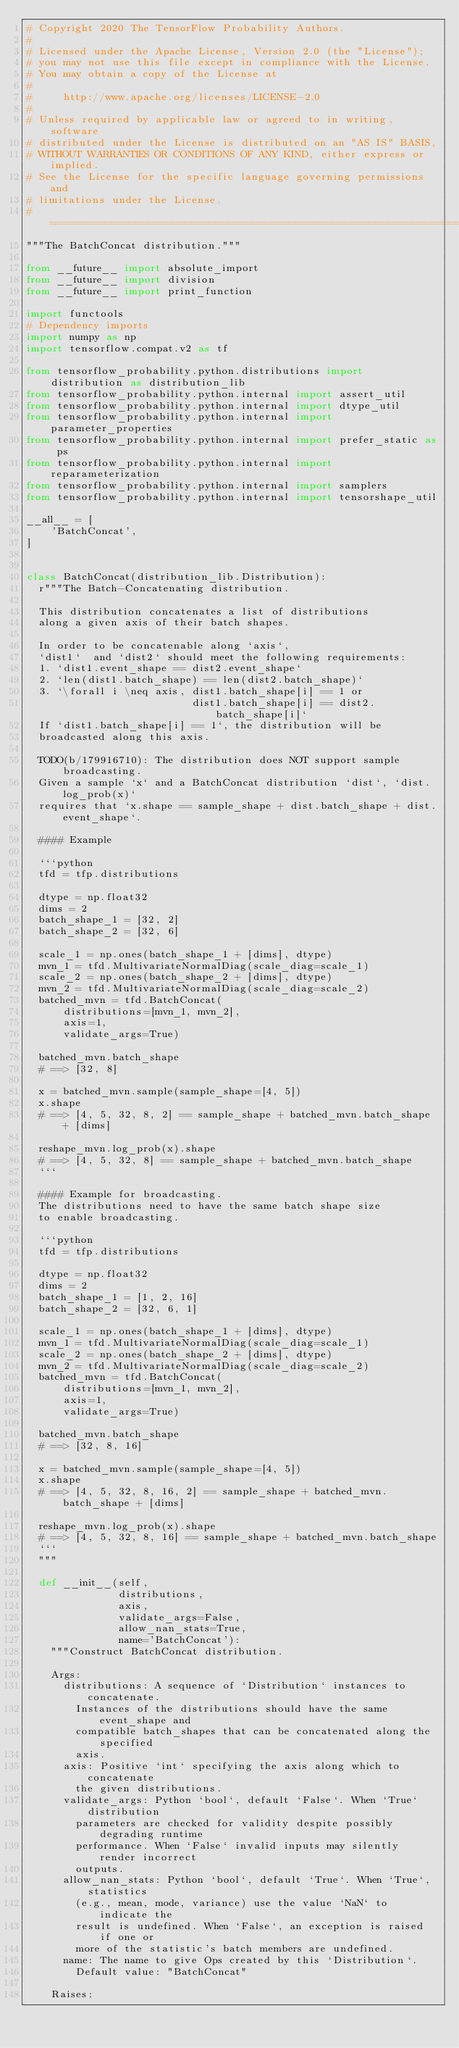<code> <loc_0><loc_0><loc_500><loc_500><_Python_># Copyright 2020 The TensorFlow Probability Authors.
#
# Licensed under the Apache License, Version 2.0 (the "License");
# you may not use this file except in compliance with the License.
# You may obtain a copy of the License at
#
#     http://www.apache.org/licenses/LICENSE-2.0
#
# Unless required by applicable law or agreed to in writing, software
# distributed under the License is distributed on an "AS IS" BASIS,
# WITHOUT WARRANTIES OR CONDITIONS OF ANY KIND, either express or implied.
# See the License for the specific language governing permissions and
# limitations under the License.
# ============================================================================
"""The BatchConcat distribution."""

from __future__ import absolute_import
from __future__ import division
from __future__ import print_function

import functools
# Dependency imports
import numpy as np
import tensorflow.compat.v2 as tf

from tensorflow_probability.python.distributions import distribution as distribution_lib
from tensorflow_probability.python.internal import assert_util
from tensorflow_probability.python.internal import dtype_util
from tensorflow_probability.python.internal import parameter_properties
from tensorflow_probability.python.internal import prefer_static as ps
from tensorflow_probability.python.internal import reparameterization
from tensorflow_probability.python.internal import samplers
from tensorflow_probability.python.internal import tensorshape_util

__all__ = [
    'BatchConcat',
]


class BatchConcat(distribution_lib.Distribution):
  r"""The Batch-Concatenating distribution.

  This distribution concatenates a list of distributions
  along a given axis of their batch shapes.

  In order to be concatenable along `axis`,
  `dist1`  and `dist2` should meet the following requirements:
  1. `dist1.event_shape == dist2.event_shape`
  2. `len(dist1.batch_shape) == len(dist2.batch_shape)`
  3. `\forall i \neq axis, dist1.batch_shape[i] == 1 or
                           dist1.batch_shape[i] == dist2.batch_shape[i]`
  If `dist1.batch_shape[i] == 1`, the distribution will be
  broadcasted along this axis.

  TODO(b/179916710): The distribution does NOT support sample broadcasting.
  Given a sample `x` and a BatchConcat distribution `dist`, `dist.log_prob(x)`
  requires that `x.shape == sample_shape + dist.batch_shape + dist.event_shape`.

  #### Example

  ```python
  tfd = tfp.distributions

  dtype = np.float32
  dims = 2
  batch_shape_1 = [32, 2]
  batch_shape_2 = [32, 6]

  scale_1 = np.ones(batch_shape_1 + [dims], dtype)
  mvn_1 = tfd.MultivariateNormalDiag(scale_diag=scale_1)
  scale_2 = np.ones(batch_shape_2 + [dims], dtype)
  mvn_2 = tfd.MultivariateNormalDiag(scale_diag=scale_2)
  batched_mvn = tfd.BatchConcat(
      distributions=[mvn_1, mvn_2],
      axis=1,
      validate_args=True)

  batched_mvn.batch_shape
  # ==> [32, 8]

  x = batched_mvn.sample(sample_shape=[4, 5])
  x.shape
  # ==> [4, 5, 32, 8, 2] == sample_shape + batched_mvn.batch_shape + [dims]

  reshape_mvn.log_prob(x).shape
  # ==> [4, 5, 32, 8] == sample_shape + batched_mvn.batch_shape
  ```

  #### Example for broadcasting.
  The distributions need to have the same batch shape size
  to enable broadcasting.

  ```python
  tfd = tfp.distributions

  dtype = np.float32
  dims = 2
  batch_shape_1 = [1, 2, 16]
  batch_shape_2 = [32, 6, 1]

  scale_1 = np.ones(batch_shape_1 + [dims], dtype)
  mvn_1 = tfd.MultivariateNormalDiag(scale_diag=scale_1)
  scale_2 = np.ones(batch_shape_2 + [dims], dtype)
  mvn_2 = tfd.MultivariateNormalDiag(scale_diag=scale_2)
  batched_mvn = tfd.BatchConcat(
      distributions=[mvn_1, mvn_2],
      axis=1,
      validate_args=True)

  batched_mvn.batch_shape
  # ==> [32, 8, 16]

  x = batched_mvn.sample(sample_shape=[4, 5])
  x.shape
  # ==> [4, 5, 32, 8, 16, 2] == sample_shape + batched_mvn.batch_shape + [dims]

  reshape_mvn.log_prob(x).shape
  # ==> [4, 5, 32, 8, 16] == sample_shape + batched_mvn.batch_shape
  ```
  """

  def __init__(self,
               distributions,
               axis,
               validate_args=False,
               allow_nan_stats=True,
               name='BatchConcat'):
    """Construct BatchConcat distribution.

    Args:
      distributions: A sequence of `Distribution` instances to concatenate.
        Instances of the distributions should have the same event_shape and
        compatible batch_shapes that can be concatenated along the specified
        axis.
      axis: Positive `int` specifying the axis along which to concatenate
        the given distributions.
      validate_args: Python `bool`, default `False`. When `True` distribution
        parameters are checked for validity despite possibly degrading runtime
        performance. When `False` invalid inputs may silently render incorrect
        outputs.
      allow_nan_stats: Python `bool`, default `True`. When `True`, statistics
        (e.g., mean, mode, variance) use the value `NaN` to indicate the
        result is undefined. When `False`, an exception is raised if one or
        more of the statistic's batch members are undefined.
      name: The name to give Ops created by this `Distribution`.
        Default value: "BatchConcat"

    Raises:</code> 